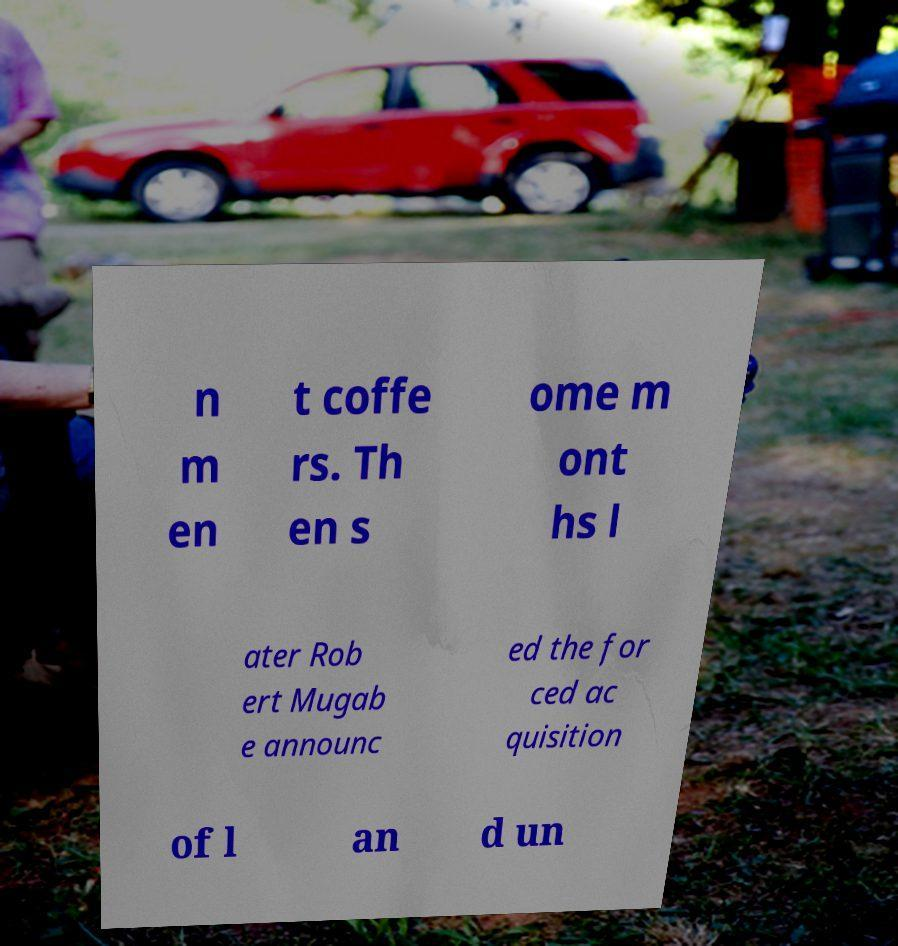Please read and relay the text visible in this image. What does it say? n m en t coffe rs. Th en s ome m ont hs l ater Rob ert Mugab e announc ed the for ced ac quisition of l an d un 